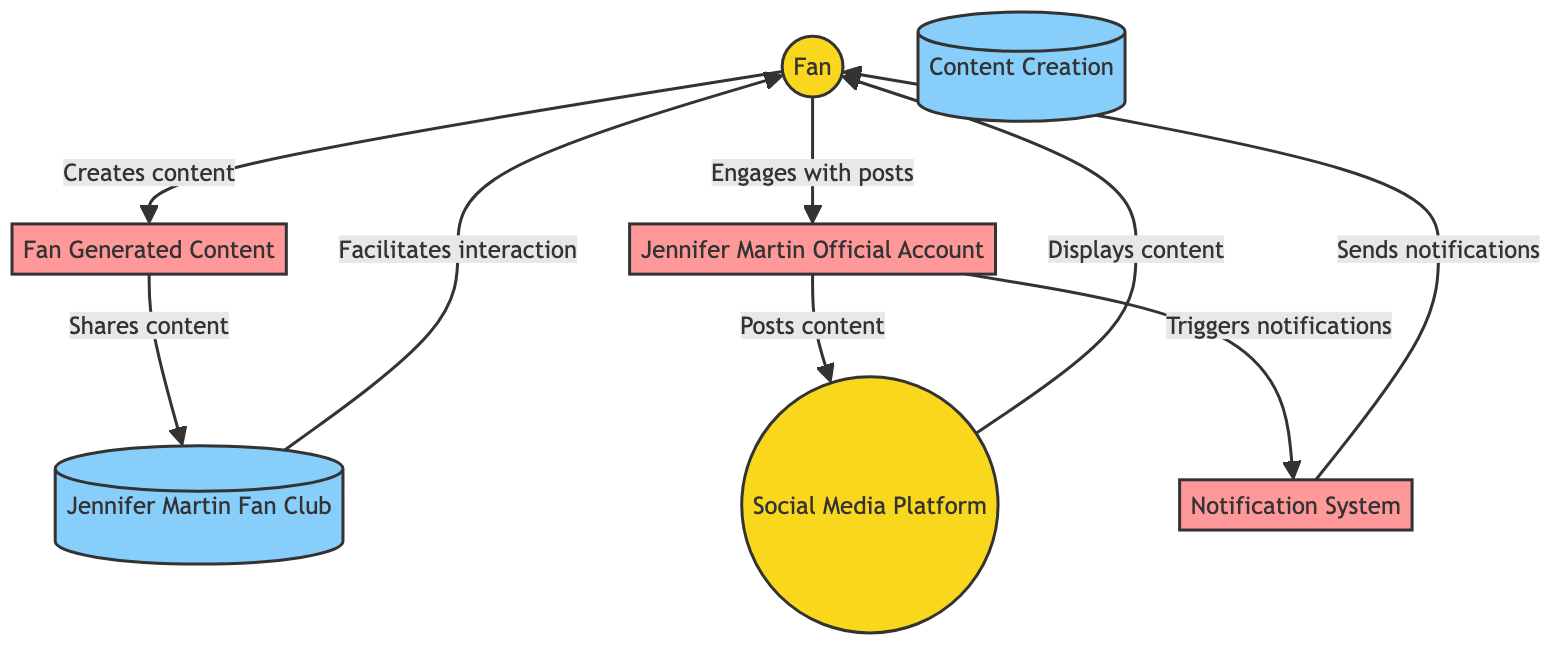What is the role of the Fan in the diagram? The Fan is depicted as an external entity in the diagram. Their role includes creating content, engaging with posts, and interacting with the fan club.
Answer: External entity How many processes are identified in the diagram? The diagram highlights four processes: Jennifer Martin Official Account, Fan Generated Content, Notification System, and Content Creation.
Answer: Four What type of interaction does the Fan have with the Jennifer Martin Official Account? The Fan engages with the Jennifer Martin Official Account by liking, sharing, and commenting on posts.
Answer: Engages Which entity sends notifications to fans? The notifications are generated by the Notification System, which is triggered by new posts from the Jennifer Martin Official Account.
Answer: Notification System What is shared within the Jennifer Martin Fan Club? Fan-generated content is shared within the Jennifer Martin Fan Club for further interaction among fans.
Answer: Fan-generated content How do fans receive updates about new content? Fans receive updates through the Notification System, which sends out notifications about new posts or interactions from the Jennifer Martin Official Account.
Answer: Notification System What is the main purpose of the Social Media Platform in the diagram? The Social Media Platform serves as a place where fans can view and interact with content posted by the Jennifer Martin Official Account.
Answer: View and interact Which process creates content that is stored in the Content Creation data store? The process known as Fan Generated Content represents the creation of posts, comments, and discussions made by fans that are stored in the Content Creation repository.
Answer: Fan Generated Content 